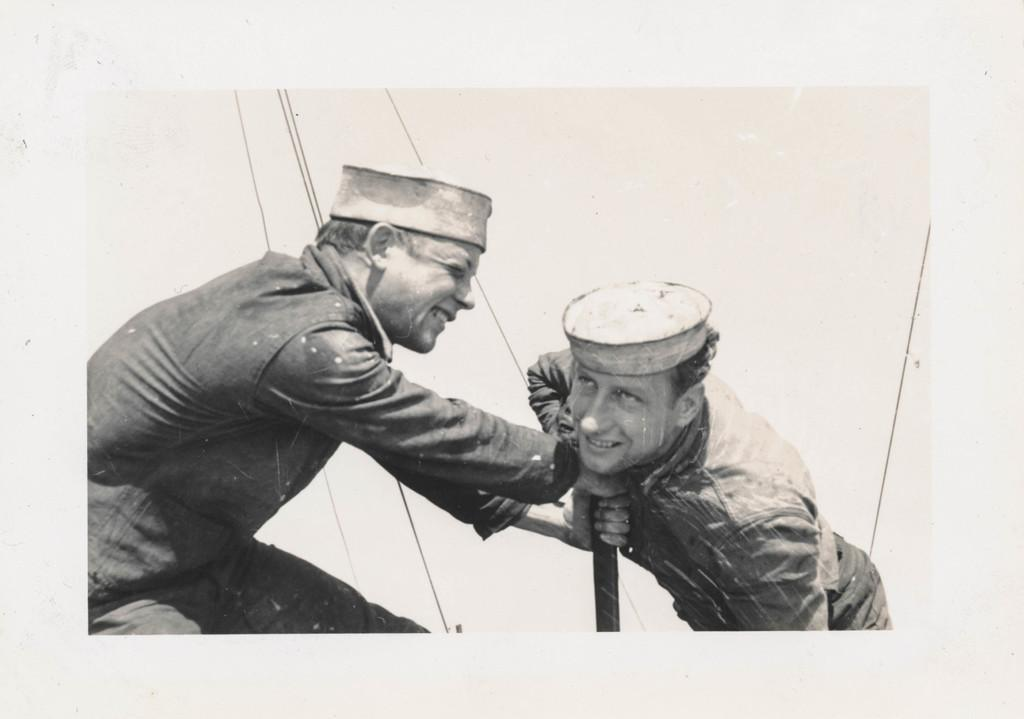What is the color scheme of the image? The image is black and white. How many people are in the image? There are two men standing in the image. What are the men wearing on their heads? The men are wearing caps. What type of clothing are the men wearing on their upper bodies? The men are wearing shirts. What structure can be seen in the image? There appears to be a pole in the image. What type of account does the clam have in the image? There is no clam present in the image, so it is not possible to determine if it has an account or not. 